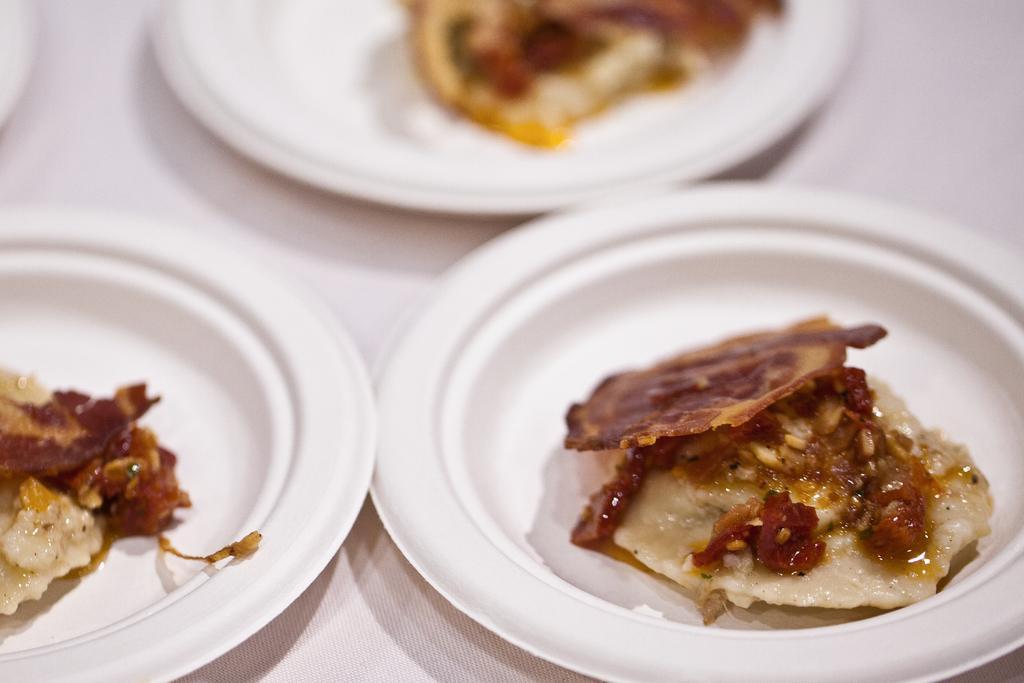Please provide a concise description of this image. In this picture we can see there are three plates on an object and on the plates there are some food items. 